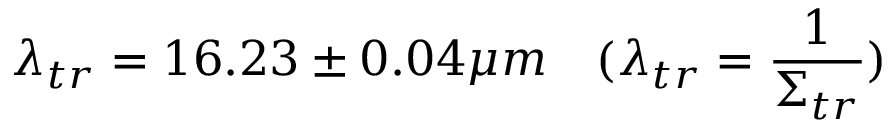<formula> <loc_0><loc_0><loc_500><loc_500>\lambda _ { t r } = 1 6 . 2 3 \pm 0 . 0 4 \mu m \quad ( \lambda _ { t r } = \frac { 1 } { \Sigma _ { t r } } )</formula> 